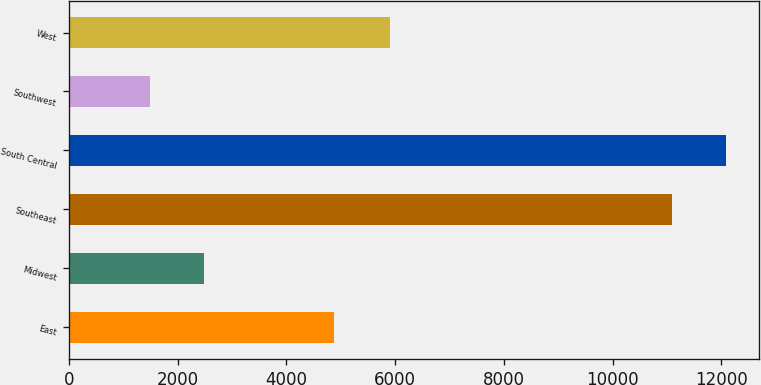Convert chart to OTSL. <chart><loc_0><loc_0><loc_500><loc_500><bar_chart><fcel>East<fcel>Midwest<fcel>Southeast<fcel>South Central<fcel>Southwest<fcel>West<nl><fcel>4880<fcel>2494.6<fcel>11093<fcel>12088.6<fcel>1499<fcel>5910<nl></chart> 